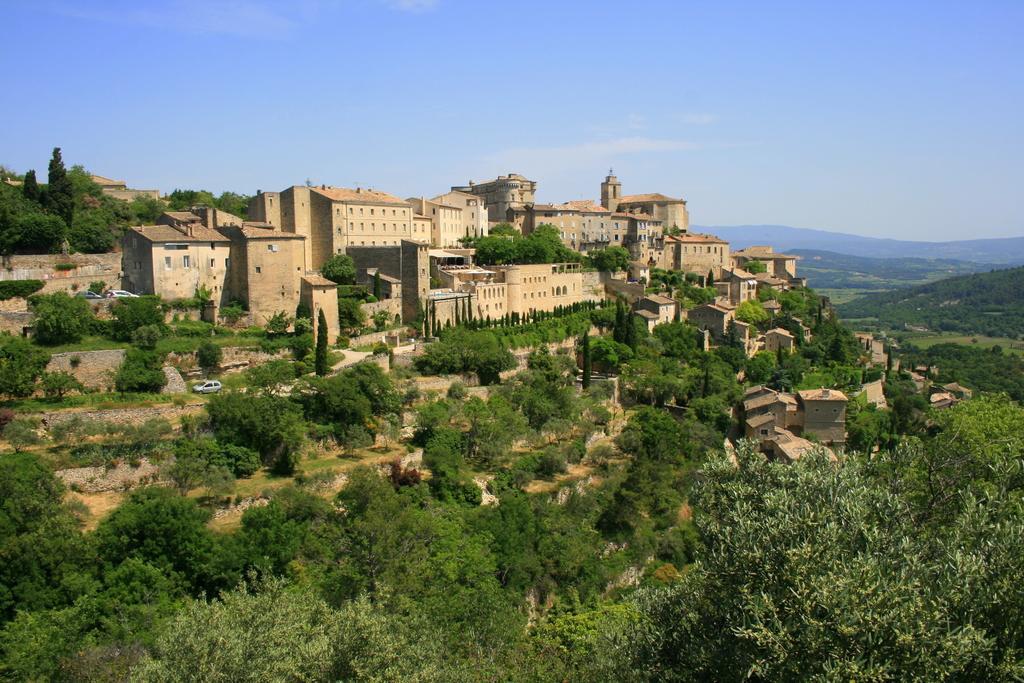Can you describe this image briefly? In this picture I can see the trees at the bottom, in the middle there are buildings. At the top I can see the sky. 